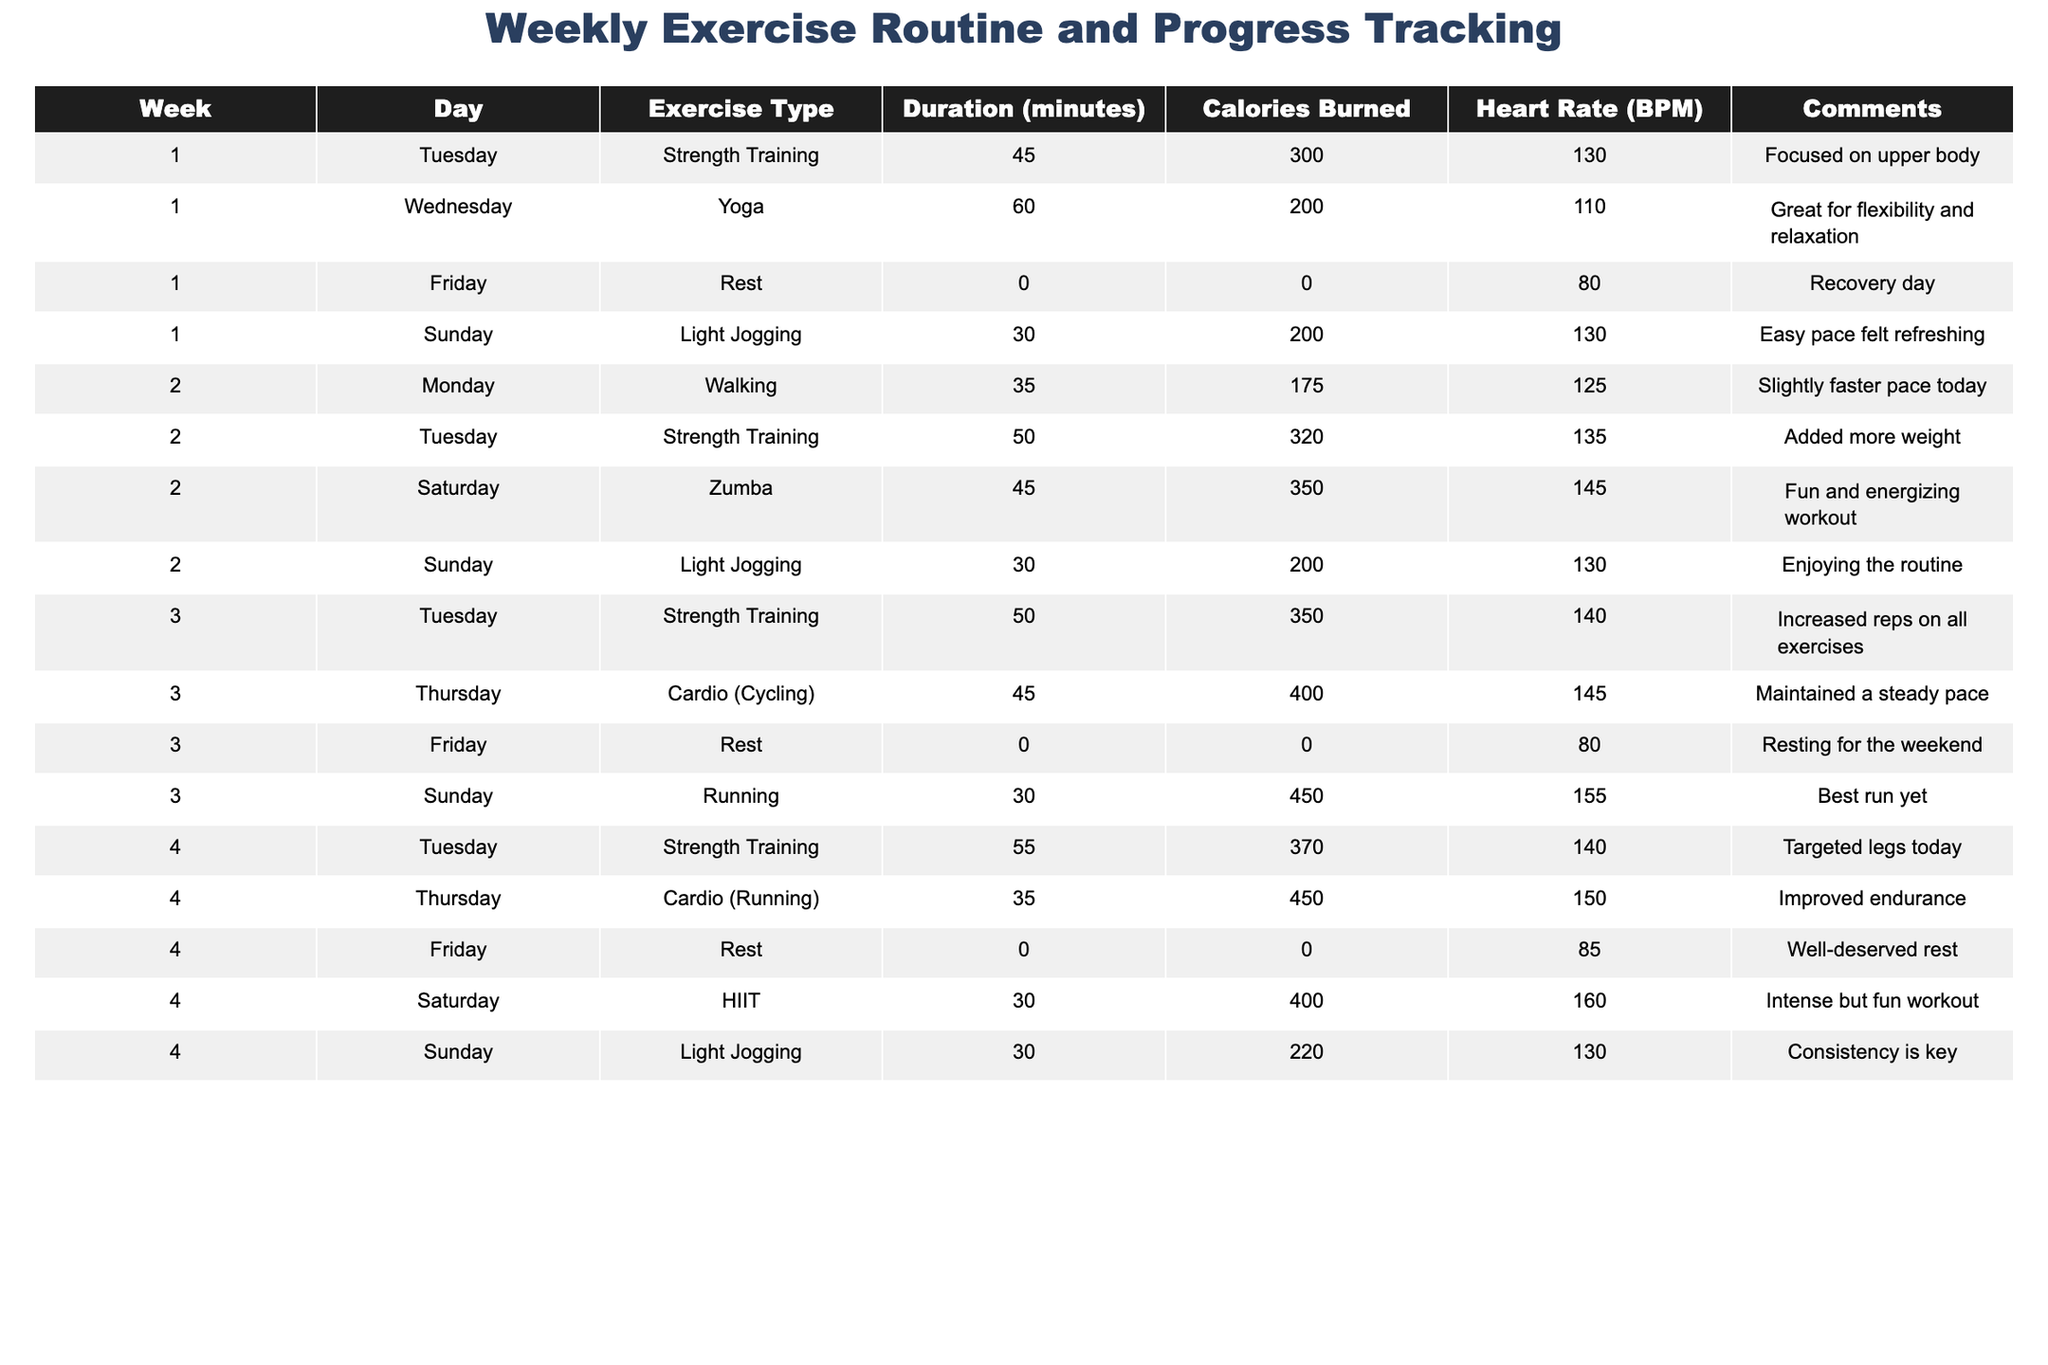What was the total duration of exercise for Week 1? In Week 1, the durations were 45 minutes (Tuesday), 60 minutes (Wednesday), 0 minutes (Friday), and 30 minutes (Sunday). Adding these gives 45 + 60 + 0 + 30 = 135 minutes.
Answer: 135 minutes On which day did the highest calories get burned in Week 3? In Week 3, the calories burned were 350 on Tuesday, 400 on Thursday, 0 on Friday, and 450 on Sunday. The highest was on Sunday with 450 calories.
Answer: Sunday What type of exercise was done on Saturday of Week 2? On Saturday of Week 2, the exercise type was Zumba.
Answer: Zumba Was there a rest day in Week 4? Yes, Friday in Week 4 was designated as a rest day with 0 minutes of exercise.
Answer: Yes What was the average heart rate during the light jogging sessions across all weeks? Light jogging was done in Week 1 (130 BPM), Week 2 (130 BPM), Week 3 (not applicable), and Week 4 (130 BPM). Summing those gives 130 + 130 + 130 = 390, then divide by 3 sessions: 390/3 = 130 BPM.
Answer: 130 BPM Which exercise type had the maximum duration in Week 4? In Week 4, the exercise durations were 55 minutes (Strength Training), 35 minutes (Running), 0 minutes (Rest), 30 minutes (HIIT), and 30 minutes (Light Jogging). The maximum is 55 minutes for Strength Training.
Answer: Strength Training How many total calories were burned throughout Week 2? In Week 2, the calories burned were 175 (Walking), 320 (Strength Training), 350 (Zumba), and 200 (Light Jogging). Adding these gives 175 + 320 + 350 + 200 = 1045 calories.
Answer: 1045 calories Was the heart rate higher during the HIIT session compared to the Strength Training session in Week 4? In Week 4, the heart rate for HIIT was 160 BPM and for Strength Training was 140 BPM. 160 is higher than 140.
Answer: Yes Which week had the most consistent exercise type across all days? Week 1 had varied types with Strength Training, Yoga, Rest, and Light Jogging; Week 2 saw Walking, Strength Training, Zumba, and Light Jogging; whereas Week 4 had Strength Training, Running, Rest, HIIT, and Light Jogging. None had a single type across all days so it's a mixed result. However, Week 4 had a consistent pattern with both running and jogging types on various days.
Answer: Week 4 How much more duration was allocated to strength training in Week 3 compared to Week 1? In Week 3, strength training lasted 50 minutes, while in Week 1 it was 45 minutes. The difference is 50 - 45 = 5 minutes more.
Answer: 5 minutes What was the total number of exercise sessions recorded for the entire period? There are 12 sessions in total across the 4 weeks, with specific exercises logged each week. Counting all the entries gives us 12 sessions.
Answer: 12 sessions 